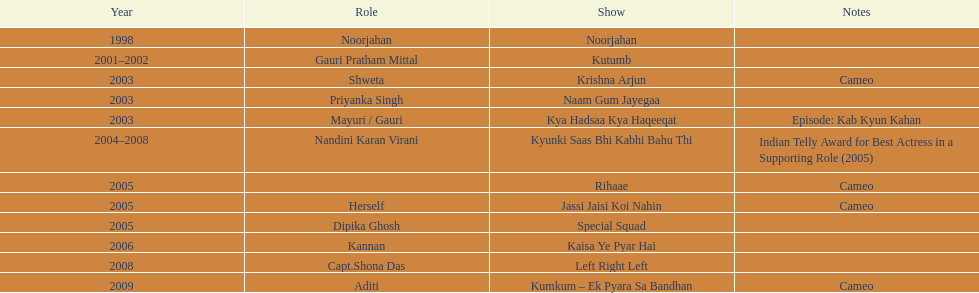What was the maximum number of years a show continued? 4. 